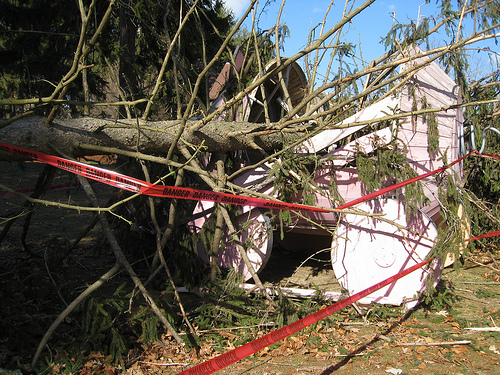<image>
Is the tree behind the cover? Yes. From this viewpoint, the tree is positioned behind the cover, with the cover partially or fully occluding the tree. 